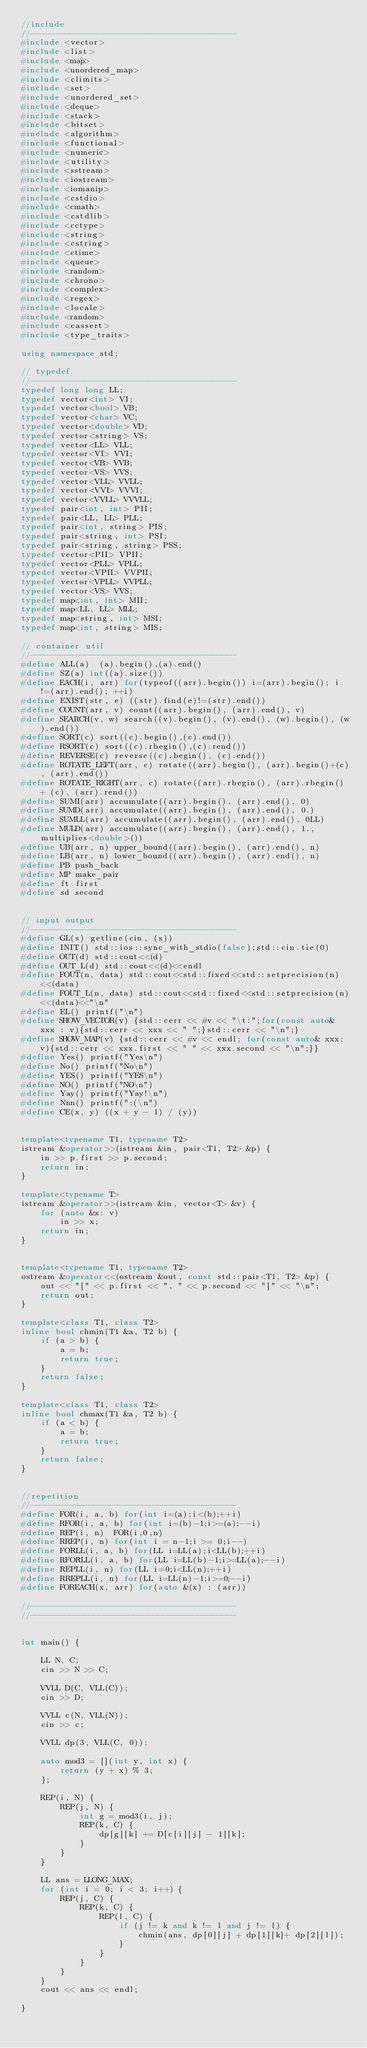Convert code to text. <code><loc_0><loc_0><loc_500><loc_500><_C++_>//include
//------------------------------------------
#include <vector>
#include <list>
#include <map>
#include <unordered_map>
#include <climits>
#include <set>
#include <unordered_set>
#include <deque>
#include <stack>
#include <bitset>
#include <algorithm>
#include <functional>
#include <numeric>
#include <utility>
#include <sstream>
#include <iostream>
#include <iomanip>
#include <cstdio>
#include <cmath>
#include <cstdlib>
#include <cctype>
#include <string>
#include <cstring>
#include <ctime>
#include <queue>
#include <random>
#include <chrono>
#include <complex>
#include <regex>
#include <locale>
#include <random>
#include <cassert>
#include <type_traits>

using namespace std;

// typedef
//------------------------------------------
typedef long long LL;
typedef vector<int> VI;
typedef vector<bool> VB;
typedef vector<char> VC;
typedef vector<double> VD;
typedef vector<string> VS;
typedef vector<LL> VLL;
typedef vector<VI> VVI;
typedef vector<VB> VVB;
typedef vector<VS> VVS;
typedef vector<VLL> VVLL;
typedef vector<VVI> VVVI;
typedef vector<VVLL> VVVLL;
typedef pair<int, int> PII;
typedef pair<LL, LL> PLL;
typedef pair<int, string> PIS;
typedef pair<string, int> PSI;
typedef pair<string, string> PSS;
typedef vector<PII> VPII;
typedef vector<PLL> VPLL;
typedef vector<VPII> VVPII;
typedef vector<VPLL> VVPLL;
typedef vector<VS> VVS;
typedef map<int, int> MII;
typedef map<LL, LL> MLL;
typedef map<string, int> MSI;
typedef map<int, string> MIS;

// container util
//------------------------------------------
#define ALL(a)  (a).begin(),(a).end()
#define SZ(a) int((a).size())
#define EACH(i, arr) for(typeof((arr).begin()) i=(arr).begin(); i!=(arr).end(); ++i)
#define EXIST(str, e) ((str).find(e)!=(str).end())
#define COUNT(arr, v) count((arr).begin(), (arr).end(), v)
#define SEARCH(v, w) search((v).begin(), (v).end(), (w).begin(), (w).end())
#define SORT(c) sort((c).begin(),(c).end())
#define RSORT(c) sort((c).rbegin(),(c).rend())
#define REVERSE(c) reverse((c).begin(), (c).end())
#define ROTATE_LEFT(arr, c) rotate((arr).begin(), (arr).begin()+(c), (arr).end())
#define ROTATE_RIGHT(arr, c) rotate((arr).rbegin(), (arr).rbegin() + (c), (arr).rend())
#define SUMI(arr) accumulate((arr).begin(), (arr).end(), 0)
#define SUMD(arr) accumulate((arr).begin(), (arr).end(), 0.)
#define SUMLL(arr) accumulate((arr).begin(), (arr).end(), 0LL)
#define MULD(arr) accumulate((arr).begin(), (arr).end(), 1., multiplies<double>())
#define UB(arr, n) upper_bound((arr).begin(), (arr).end(), n)
#define LB(arr, n) lower_bound((arr).begin(), (arr).end(), n)
#define PB push_back
#define MP make_pair
#define ft first
#define sd second


// input output
//------------------------------------------
#define GL(s) getline(cin, (s))
#define INIT() std::ios::sync_with_stdio(false);std::cin.tie(0)
#define OUT(d) std::cout<<(d)
#define OUT_L(d) std::cout<<(d)<<endl
#define FOUT(n, data) std::cout<<std::fixed<<std::setprecision(n)<<(data)
#define FOUT_L(n, data) std::cout<<std::fixed<<std::setprecision(n)<<(data)<<"\n"
#define EL() printf("\n")
#define SHOW_VECTOR(v) {std::cerr << #v << "\t:";for(const auto& xxx : v){std::cerr << xxx << " ";}std::cerr << "\n";}
#define SHOW_MAP(v) {std::cerr << #v << endl; for(const auto& xxx: v){std::cerr << xxx.first << " " << xxx.second << "\n";}}
#define Yes() printf("Yes\n")
#define No() printf("No\n")
#define YES() printf("YES\n")
#define NO() printf("NO\n")
#define Yay() printf("Yay!\n")
#define Nnn() printf(":(\n")
#define CE(x, y) ((x + y - 1) / (y))


template<typename T1, typename T2>
istream &operator>>(istream &in, pair<T1, T2> &p) {
    in >> p.first >> p.second;
    return in;
}

template<typename T>
istream &operator>>(istream &in, vector<T> &v) {
    for (auto &x: v)
        in >> x;
    return in;
}


template<typename T1, typename T2>
ostream &operator<<(ostream &out, const std::pair<T1, T2> &p) {
    out << "[" << p.first << ", " << p.second << "]" << "\n";
    return out;
}

template<class T1, class T2>
inline bool chmin(T1 &a, T2 b) {
    if (a > b) {
        a = b;
        return true;
    }
    return false;
}

template<class T1, class T2>
inline bool chmax(T1 &a, T2 b) {
    if (a < b) {
        a = b;
        return true;
    }
    return false;
}


//repetition
//------------------------------------------
#define FOR(i, a, b) for(int i=(a);i<(b);++i)
#define RFOR(i, a, b) for(int i=(b)-1;i>=(a);--i)
#define REP(i, n)  FOR(i,0,n)
#define RREP(i, n) for(int i = n-1;i >= 0;i--)
#define FORLL(i, a, b) for(LL i=LL(a);i<LL(b);++i)
#define RFORLL(i, a, b) for(LL i=LL(b)-1;i>=LL(a);--i)
#define REPLL(i, n) for(LL i=0;i<LL(n);++i)
#define RREPLL(i, n) for(LL i=LL(n)-1;i>=0;--i)
#define FOREACH(x, arr) for(auto &(x) : (arr))

//------------------------------------------
//------------------------------------------


int main() {

    LL N, C;
    cin >> N >> C;

    VVLL D(C, VLL(C));
    cin >> D;

    VVLL c(N, VLL(N));
    cin >> c;

    VVLL dp(3, VLL(C, 0));

    auto mod3 = [](int y, int x) {
        return (y + x) % 3;
    };

    REP(i, N) {
        REP(j, N) {
            int g = mod3(i, j);
            REP(k, C) {
                dp[g][k] += D[c[i][j] - 1][k];
            }
        }
    }

    LL ans = LLONG_MAX;
    for (int i = 0; i < 3; i++) {
        REP(j, C) {
            REP(k, C) {
                REP(l, C) {
                    if (j != k and k != l and j != l) {
                        chmin(ans, dp[0][j] + dp[1][k]+ dp[2][l]);
                    }
                }
            }
        }
    }
    cout << ans << endl;

}












































</code> 